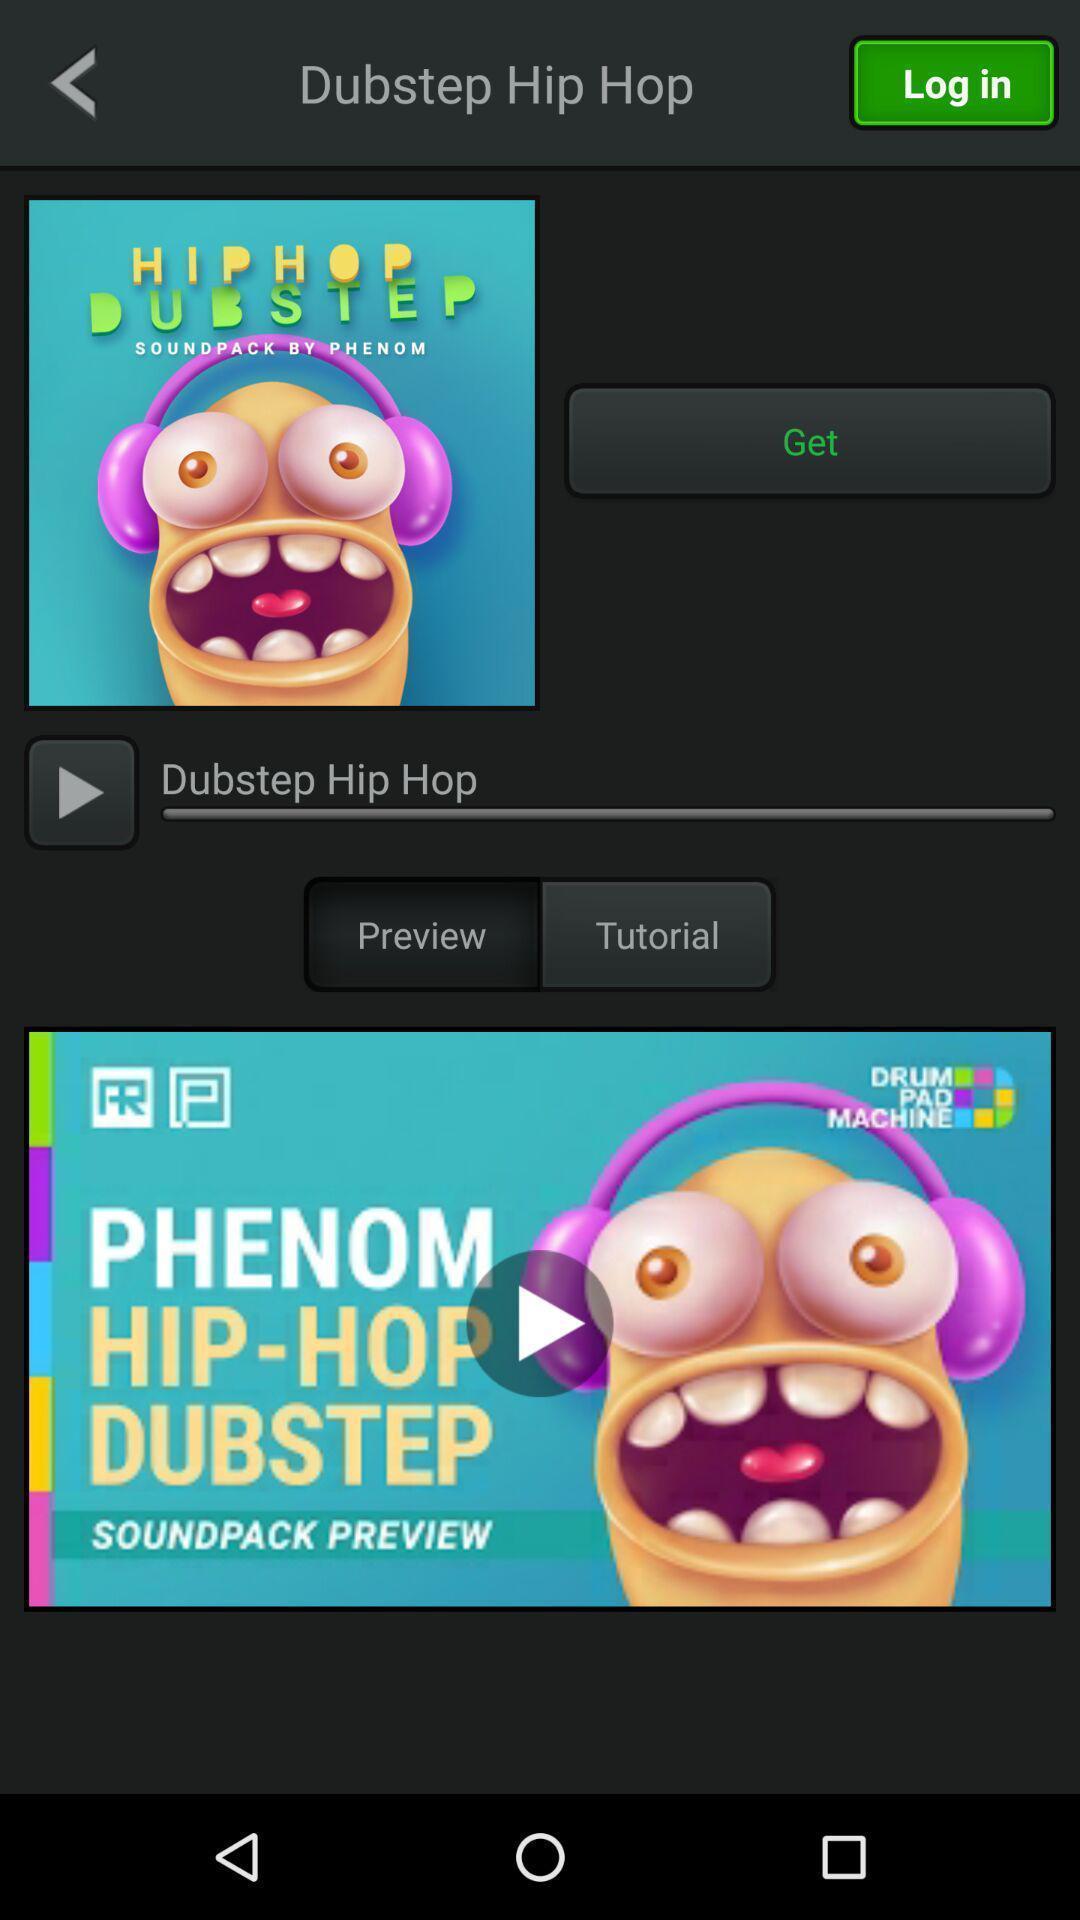Tell me about the visual elements in this screen capture. Video of the dub step hip hop. 